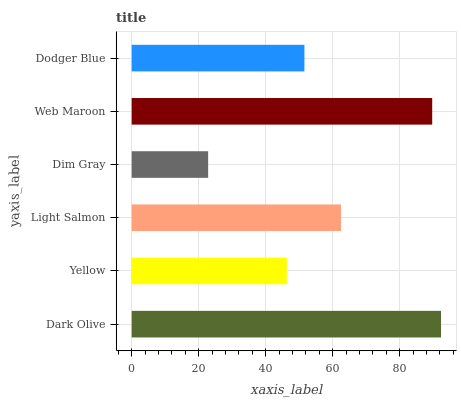Is Dim Gray the minimum?
Answer yes or no. Yes. Is Dark Olive the maximum?
Answer yes or no. Yes. Is Yellow the minimum?
Answer yes or no. No. Is Yellow the maximum?
Answer yes or no. No. Is Dark Olive greater than Yellow?
Answer yes or no. Yes. Is Yellow less than Dark Olive?
Answer yes or no. Yes. Is Yellow greater than Dark Olive?
Answer yes or no. No. Is Dark Olive less than Yellow?
Answer yes or no. No. Is Light Salmon the high median?
Answer yes or no. Yes. Is Dodger Blue the low median?
Answer yes or no. Yes. Is Dim Gray the high median?
Answer yes or no. No. Is Dim Gray the low median?
Answer yes or no. No. 